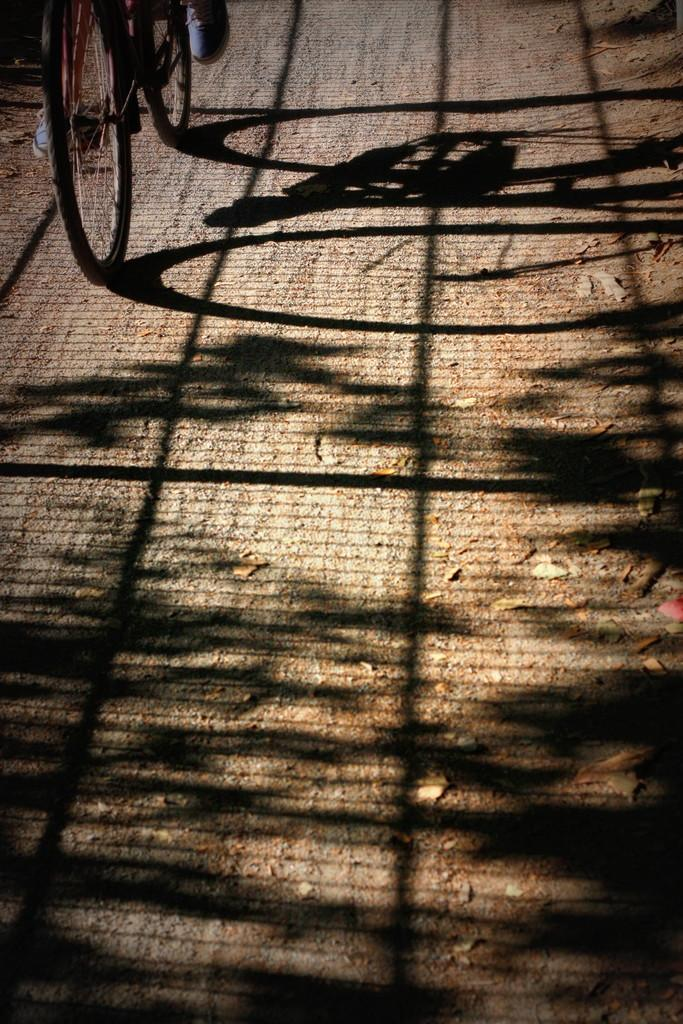What activity is being performed by the person in the image? The person is riding a bicycle in the top left corner of the image. What can be observed in the middle of the image? There is a shadow visible in the middle of the image. How many cakes are displayed on the table in the image? There is no table or cakes present in the image; it only features a person riding a bicycle and a shadow. 